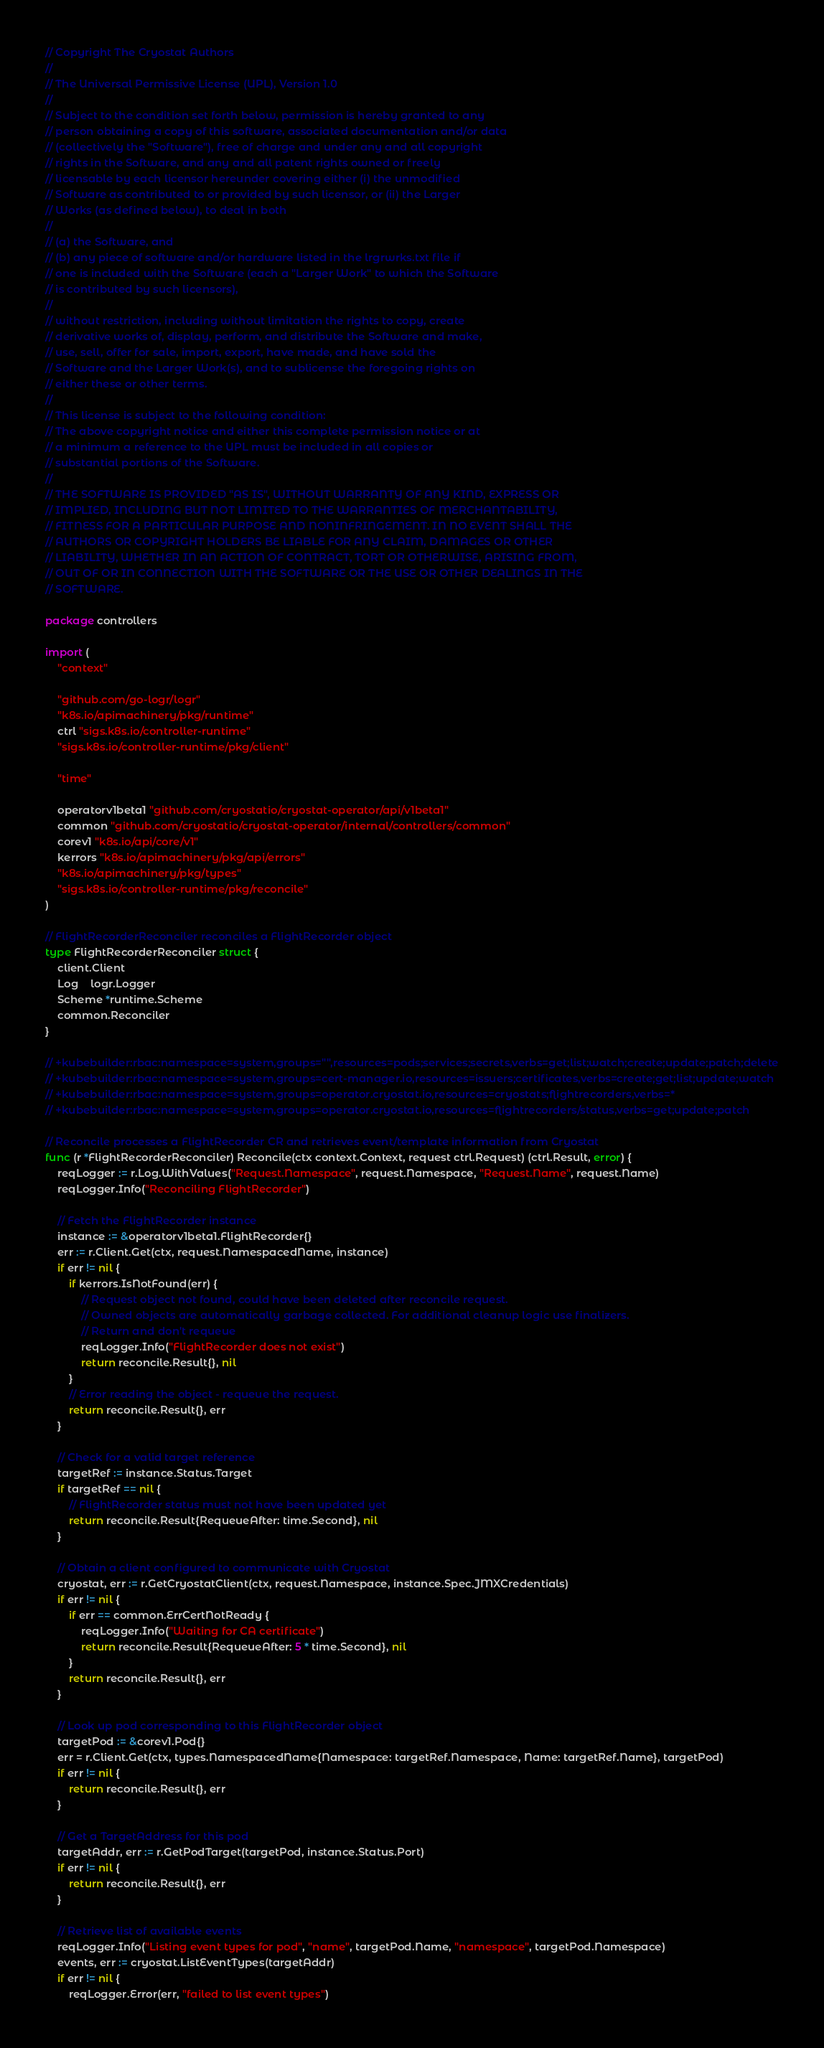Convert code to text. <code><loc_0><loc_0><loc_500><loc_500><_Go_>// Copyright The Cryostat Authors
//
// The Universal Permissive License (UPL), Version 1.0
//
// Subject to the condition set forth below, permission is hereby granted to any
// person obtaining a copy of this software, associated documentation and/or data
// (collectively the "Software"), free of charge and under any and all copyright
// rights in the Software, and any and all patent rights owned or freely
// licensable by each licensor hereunder covering either (i) the unmodified
// Software as contributed to or provided by such licensor, or (ii) the Larger
// Works (as defined below), to deal in both
//
// (a) the Software, and
// (b) any piece of software and/or hardware listed in the lrgrwrks.txt file if
// one is included with the Software (each a "Larger Work" to which the Software
// is contributed by such licensors),
//
// without restriction, including without limitation the rights to copy, create
// derivative works of, display, perform, and distribute the Software and make,
// use, sell, offer for sale, import, export, have made, and have sold the
// Software and the Larger Work(s), and to sublicense the foregoing rights on
// either these or other terms.
//
// This license is subject to the following condition:
// The above copyright notice and either this complete permission notice or at
// a minimum a reference to the UPL must be included in all copies or
// substantial portions of the Software.
//
// THE SOFTWARE IS PROVIDED "AS IS", WITHOUT WARRANTY OF ANY KIND, EXPRESS OR
// IMPLIED, INCLUDING BUT NOT LIMITED TO THE WARRANTIES OF MERCHANTABILITY,
// FITNESS FOR A PARTICULAR PURPOSE AND NONINFRINGEMENT. IN NO EVENT SHALL THE
// AUTHORS OR COPYRIGHT HOLDERS BE LIABLE FOR ANY CLAIM, DAMAGES OR OTHER
// LIABILITY, WHETHER IN AN ACTION OF CONTRACT, TORT OR OTHERWISE, ARISING FROM,
// OUT OF OR IN CONNECTION WITH THE SOFTWARE OR THE USE OR OTHER DEALINGS IN THE
// SOFTWARE.

package controllers

import (
	"context"

	"github.com/go-logr/logr"
	"k8s.io/apimachinery/pkg/runtime"
	ctrl "sigs.k8s.io/controller-runtime"
	"sigs.k8s.io/controller-runtime/pkg/client"

	"time"

	operatorv1beta1 "github.com/cryostatio/cryostat-operator/api/v1beta1"
	common "github.com/cryostatio/cryostat-operator/internal/controllers/common"
	corev1 "k8s.io/api/core/v1"
	kerrors "k8s.io/apimachinery/pkg/api/errors"
	"k8s.io/apimachinery/pkg/types"
	"sigs.k8s.io/controller-runtime/pkg/reconcile"
)

// FlightRecorderReconciler reconciles a FlightRecorder object
type FlightRecorderReconciler struct {
	client.Client
	Log    logr.Logger
	Scheme *runtime.Scheme
	common.Reconciler
}

// +kubebuilder:rbac:namespace=system,groups="",resources=pods;services;secrets,verbs=get;list;watch;create;update;patch;delete
// +kubebuilder:rbac:namespace=system,groups=cert-manager.io,resources=issuers;certificates,verbs=create;get;list;update;watch
// +kubebuilder:rbac:namespace=system,groups=operator.cryostat.io,resources=cryostats;flightrecorders,verbs=*
// +kubebuilder:rbac:namespace=system,groups=operator.cryostat.io,resources=flightrecorders/status,verbs=get;update;patch

// Reconcile processes a FlightRecorder CR and retrieves event/template information from Cryostat
func (r *FlightRecorderReconciler) Reconcile(ctx context.Context, request ctrl.Request) (ctrl.Result, error) {
	reqLogger := r.Log.WithValues("Request.Namespace", request.Namespace, "Request.Name", request.Name)
	reqLogger.Info("Reconciling FlightRecorder")

	// Fetch the FlightRecorder instance
	instance := &operatorv1beta1.FlightRecorder{}
	err := r.Client.Get(ctx, request.NamespacedName, instance)
	if err != nil {
		if kerrors.IsNotFound(err) {
			// Request object not found, could have been deleted after reconcile request.
			// Owned objects are automatically garbage collected. For additional cleanup logic use finalizers.
			// Return and don't requeue
			reqLogger.Info("FlightRecorder does not exist")
			return reconcile.Result{}, nil
		}
		// Error reading the object - requeue the request.
		return reconcile.Result{}, err
	}

	// Check for a valid target reference
	targetRef := instance.Status.Target
	if targetRef == nil {
		// FlightRecorder status must not have been updated yet
		return reconcile.Result{RequeueAfter: time.Second}, nil
	}

	// Obtain a client configured to communicate with Cryostat
	cryostat, err := r.GetCryostatClient(ctx, request.Namespace, instance.Spec.JMXCredentials)
	if err != nil {
		if err == common.ErrCertNotReady {
			reqLogger.Info("Waiting for CA certificate")
			return reconcile.Result{RequeueAfter: 5 * time.Second}, nil
		}
		return reconcile.Result{}, err
	}

	// Look up pod corresponding to this FlightRecorder object
	targetPod := &corev1.Pod{}
	err = r.Client.Get(ctx, types.NamespacedName{Namespace: targetRef.Namespace, Name: targetRef.Name}, targetPod)
	if err != nil {
		return reconcile.Result{}, err
	}

	// Get a TargetAddress for this pod
	targetAddr, err := r.GetPodTarget(targetPod, instance.Status.Port)
	if err != nil {
		return reconcile.Result{}, err
	}

	// Retrieve list of available events
	reqLogger.Info("Listing event types for pod", "name", targetPod.Name, "namespace", targetPod.Namespace)
	events, err := cryostat.ListEventTypes(targetAddr)
	if err != nil {
		reqLogger.Error(err, "failed to list event types")</code> 